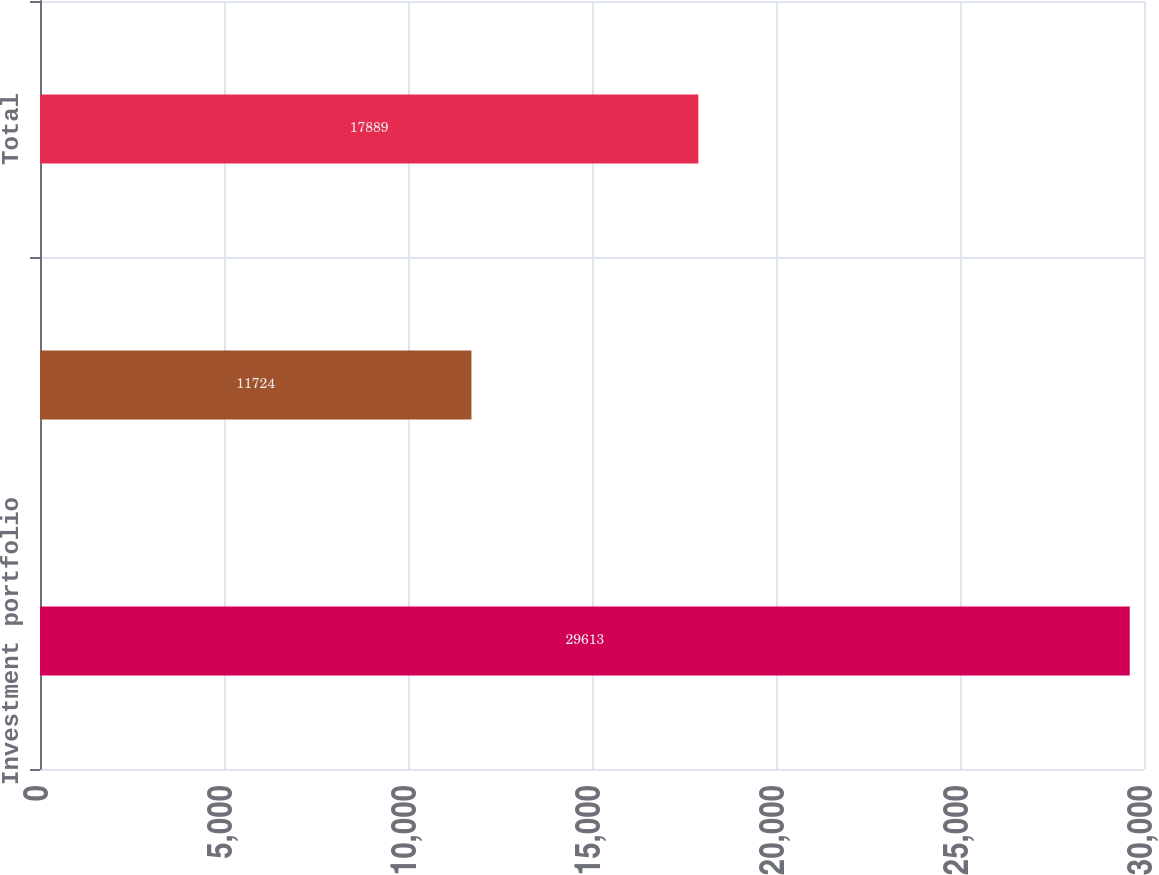Convert chart to OTSL. <chart><loc_0><loc_0><loc_500><loc_500><bar_chart><fcel>Investment portfolio<fcel>Debt<fcel>Total<nl><fcel>29613<fcel>11724<fcel>17889<nl></chart> 